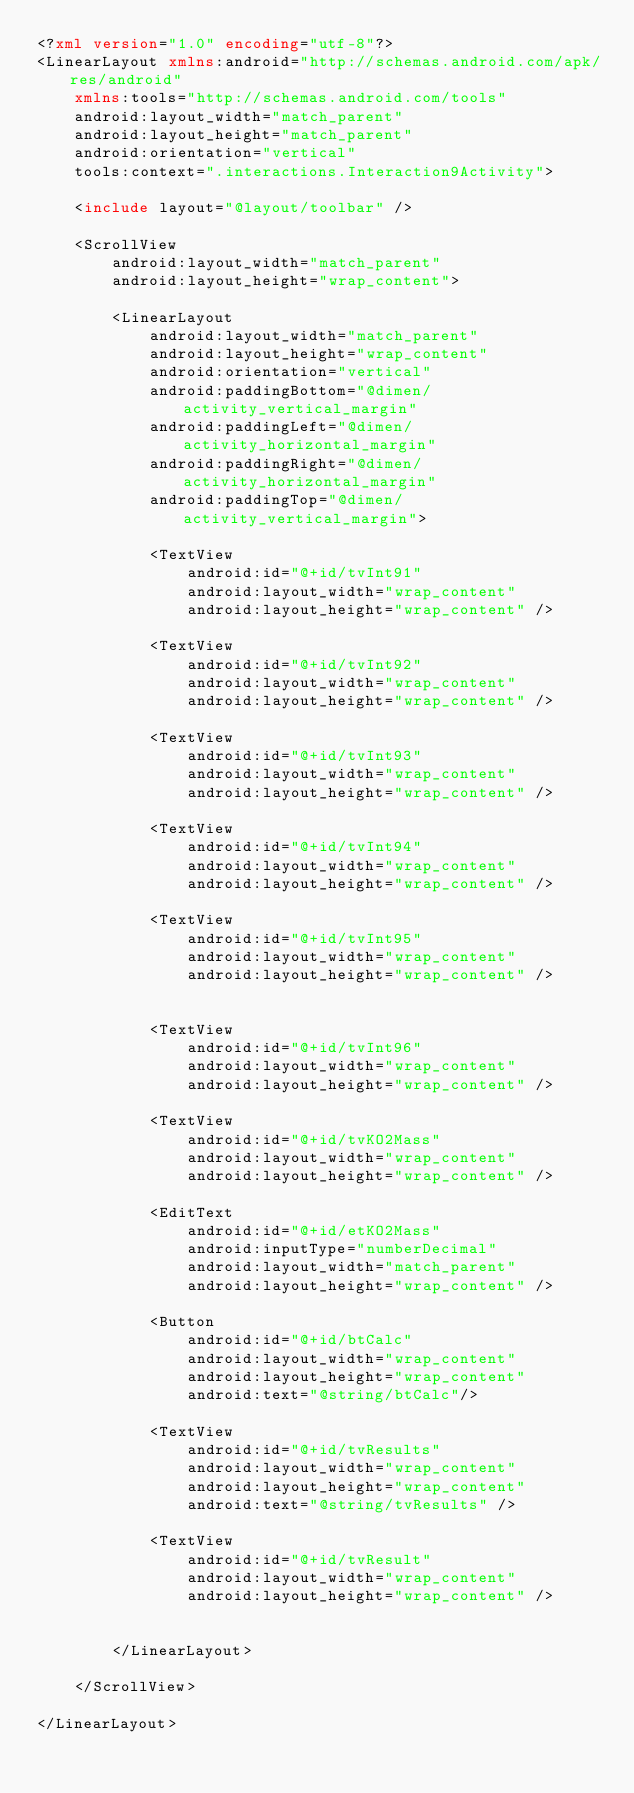Convert code to text. <code><loc_0><loc_0><loc_500><loc_500><_XML_><?xml version="1.0" encoding="utf-8"?>
<LinearLayout xmlns:android="http://schemas.android.com/apk/res/android"
    xmlns:tools="http://schemas.android.com/tools"
    android:layout_width="match_parent"
    android:layout_height="match_parent"
    android:orientation="vertical"
    tools:context=".interactions.Interaction9Activity">

    <include layout="@layout/toolbar" />

    <ScrollView
        android:layout_width="match_parent"
        android:layout_height="wrap_content">

        <LinearLayout
            android:layout_width="match_parent"
            android:layout_height="wrap_content"
            android:orientation="vertical"
            android:paddingBottom="@dimen/activity_vertical_margin"
            android:paddingLeft="@dimen/activity_horizontal_margin"
            android:paddingRight="@dimen/activity_horizontal_margin"
            android:paddingTop="@dimen/activity_vertical_margin">

            <TextView
                android:id="@+id/tvInt91"
                android:layout_width="wrap_content"
                android:layout_height="wrap_content" />

            <TextView
                android:id="@+id/tvInt92"
                android:layout_width="wrap_content"
                android:layout_height="wrap_content" />

            <TextView
                android:id="@+id/tvInt93"
                android:layout_width="wrap_content"
                android:layout_height="wrap_content" />

            <TextView
                android:id="@+id/tvInt94"
                android:layout_width="wrap_content"
                android:layout_height="wrap_content" />

            <TextView
                android:id="@+id/tvInt95"
                android:layout_width="wrap_content"
                android:layout_height="wrap_content" />


            <TextView
                android:id="@+id/tvInt96"
                android:layout_width="wrap_content"
                android:layout_height="wrap_content" />

            <TextView
                android:id="@+id/tvKO2Mass"
                android:layout_width="wrap_content"
                android:layout_height="wrap_content" />

            <EditText
                android:id="@+id/etKO2Mass"
                android:inputType="numberDecimal"
                android:layout_width="match_parent"
                android:layout_height="wrap_content" />

            <Button
                android:id="@+id/btCalc"
                android:layout_width="wrap_content"
                android:layout_height="wrap_content"
                android:text="@string/btCalc"/>
            
            <TextView
                android:id="@+id/tvResults"
                android:layout_width="wrap_content"
                android:layout_height="wrap_content"
                android:text="@string/tvResults" />

            <TextView
                android:id="@+id/tvResult"
                android:layout_width="wrap_content"
                android:layout_height="wrap_content" />


        </LinearLayout>

    </ScrollView>

</LinearLayout>
</code> 